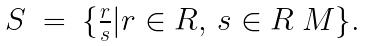<formula> <loc_0><loc_0><loc_500><loc_500>\begin{array} { l l l l } S & = & \{ \frac { r } { s } | r \in R , \, s \in R \ M \} . \\ \end{array}</formula> 